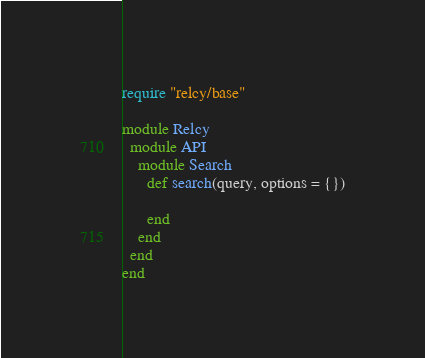Convert code to text. <code><loc_0><loc_0><loc_500><loc_500><_Ruby_>require "relcy/base"

module Relcy
  module API
    module Search
      def search(query, options = {})

      end
    end
  end
end
</code> 